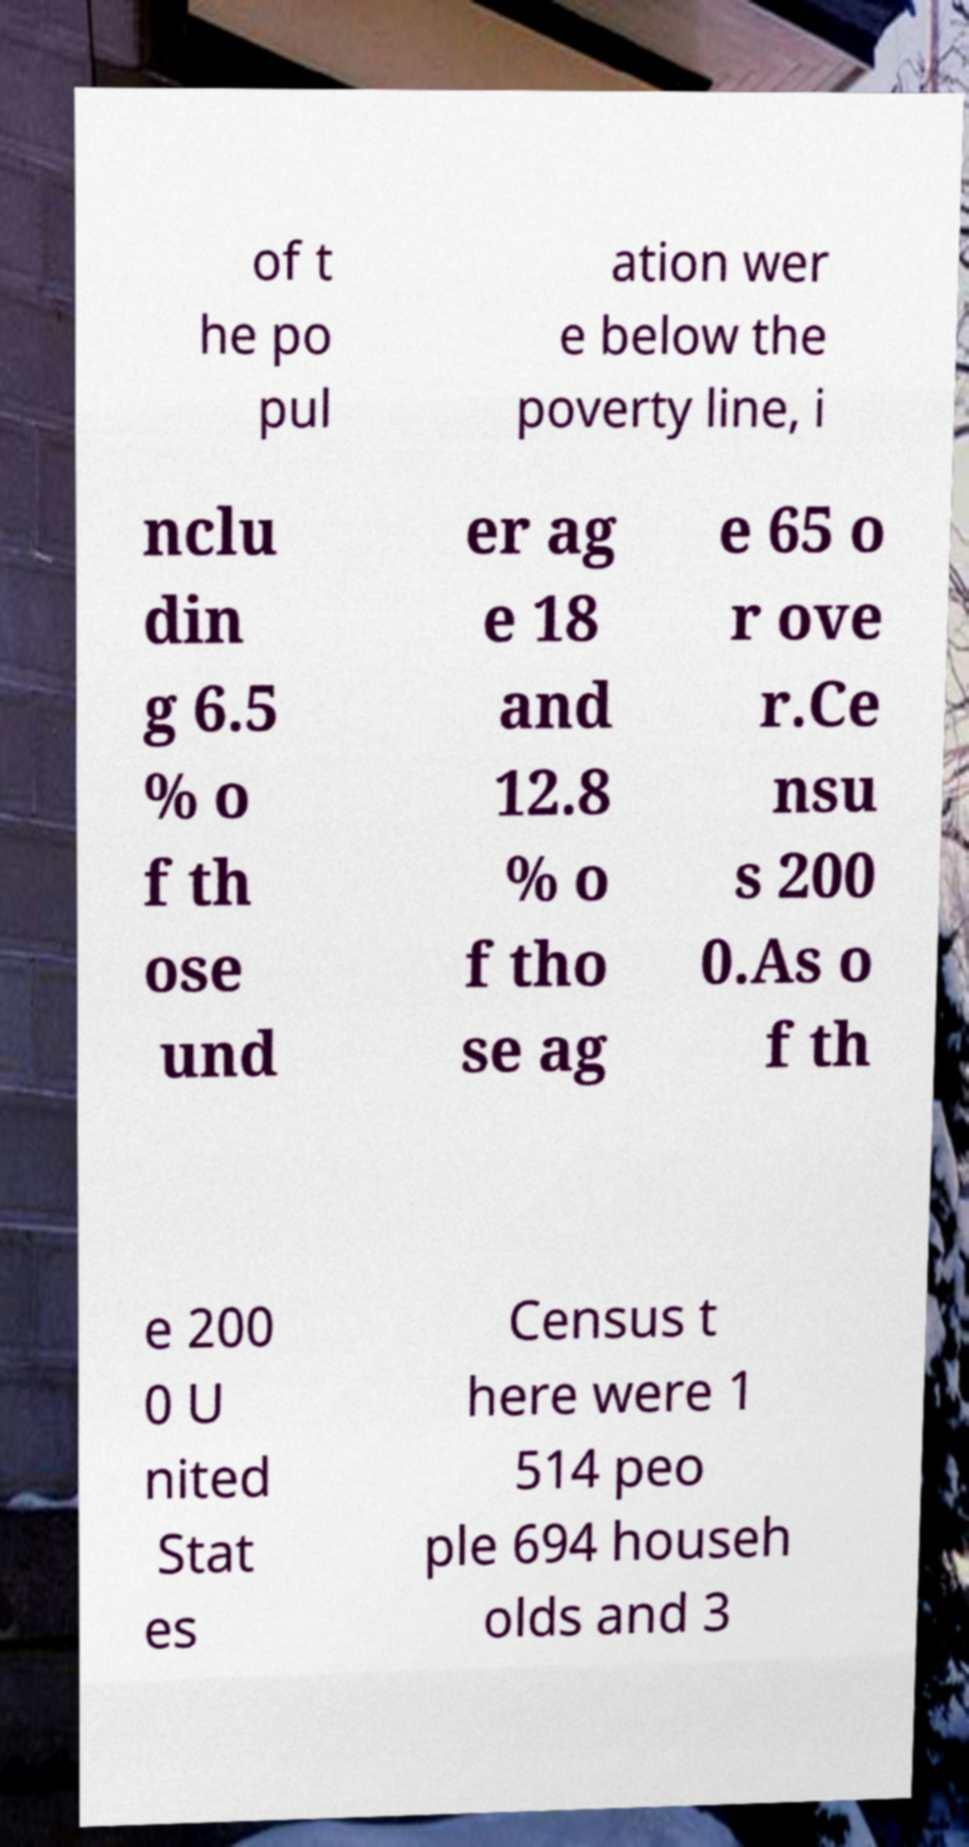Could you extract and type out the text from this image? of t he po pul ation wer e below the poverty line, i nclu din g 6.5 % o f th ose und er ag e 18 and 12.8 % o f tho se ag e 65 o r ove r.Ce nsu s 200 0.As o f th e 200 0 U nited Stat es Census t here were 1 514 peo ple 694 househ olds and 3 